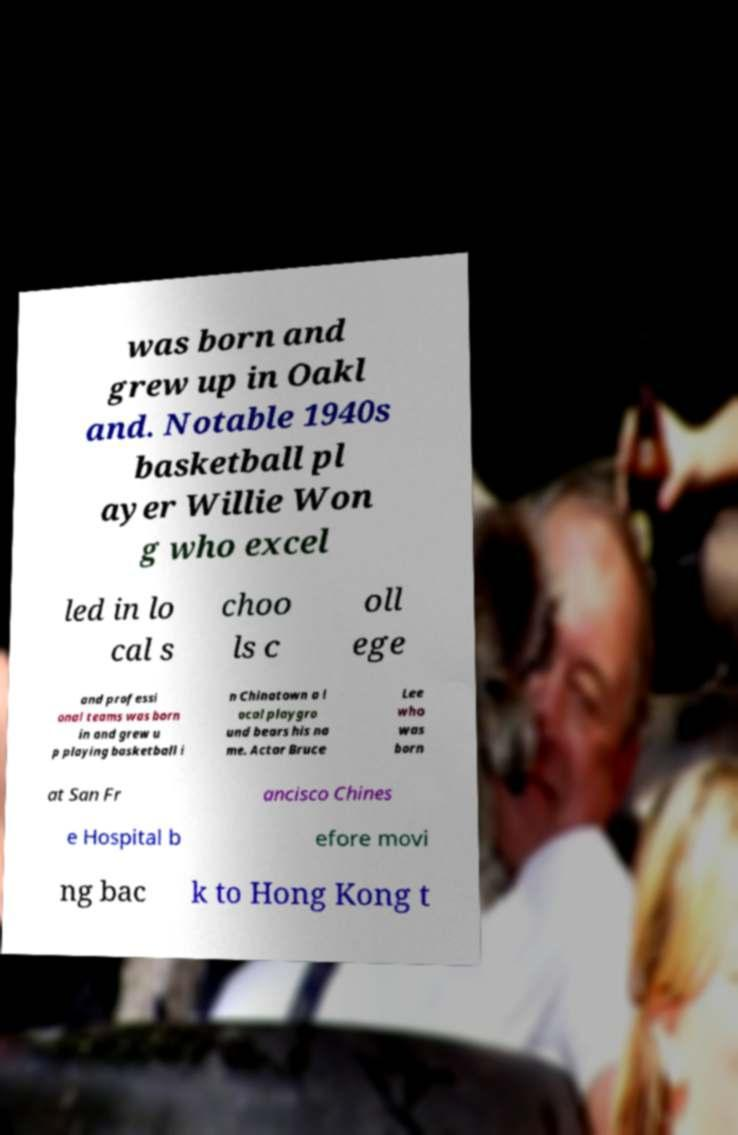What messages or text are displayed in this image? I need them in a readable, typed format. was born and grew up in Oakl and. Notable 1940s basketball pl ayer Willie Won g who excel led in lo cal s choo ls c oll ege and professi onal teams was born in and grew u p playing basketball i n Chinatown a l ocal playgro und bears his na me. Actor Bruce Lee who was born at San Fr ancisco Chines e Hospital b efore movi ng bac k to Hong Kong t 